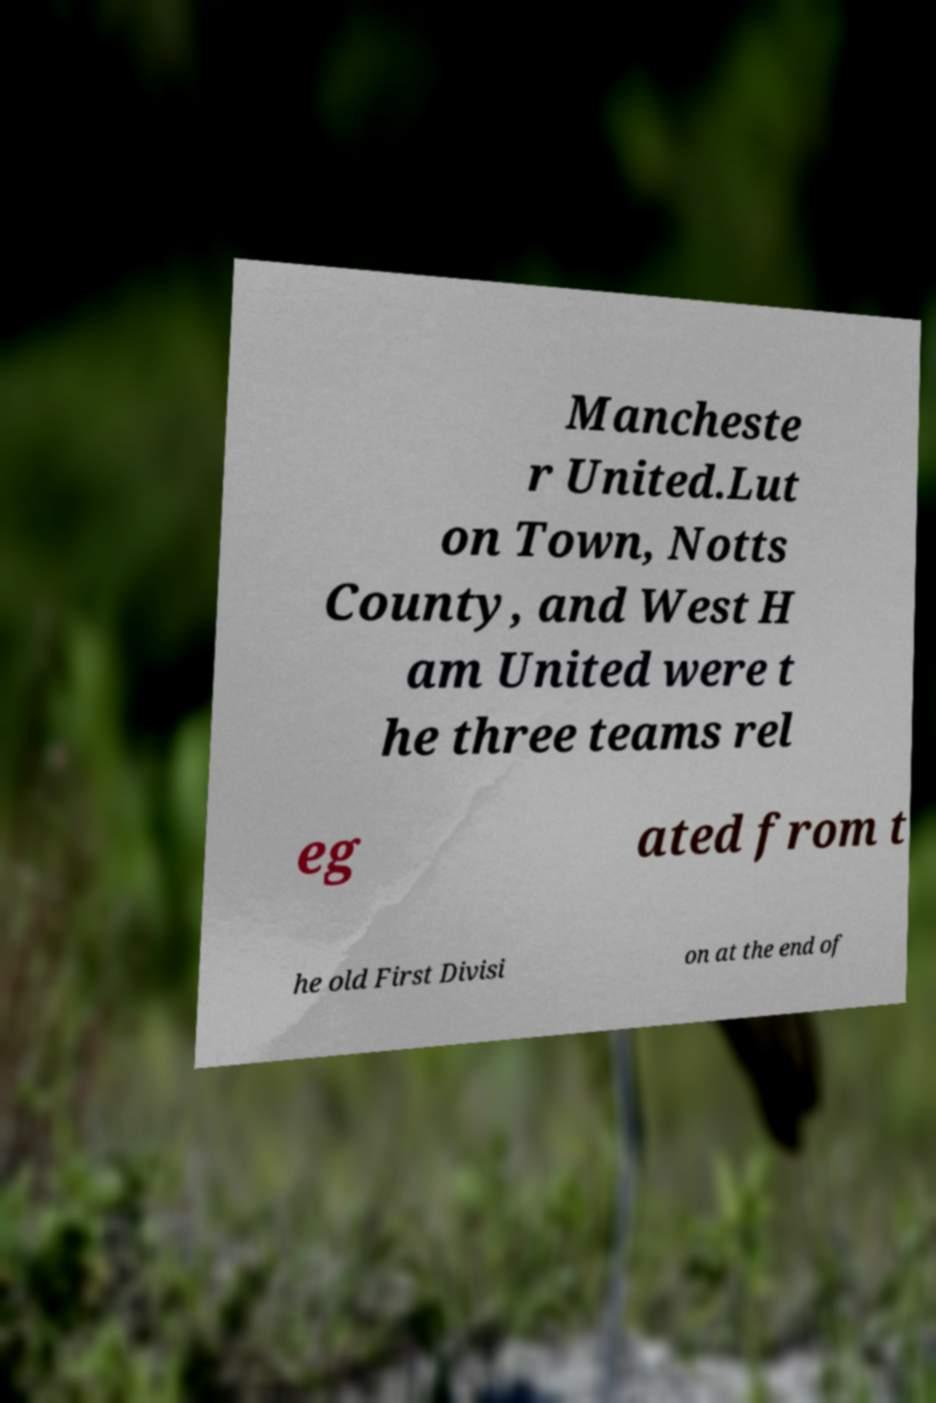There's text embedded in this image that I need extracted. Can you transcribe it verbatim? Mancheste r United.Lut on Town, Notts County, and West H am United were t he three teams rel eg ated from t he old First Divisi on at the end of 